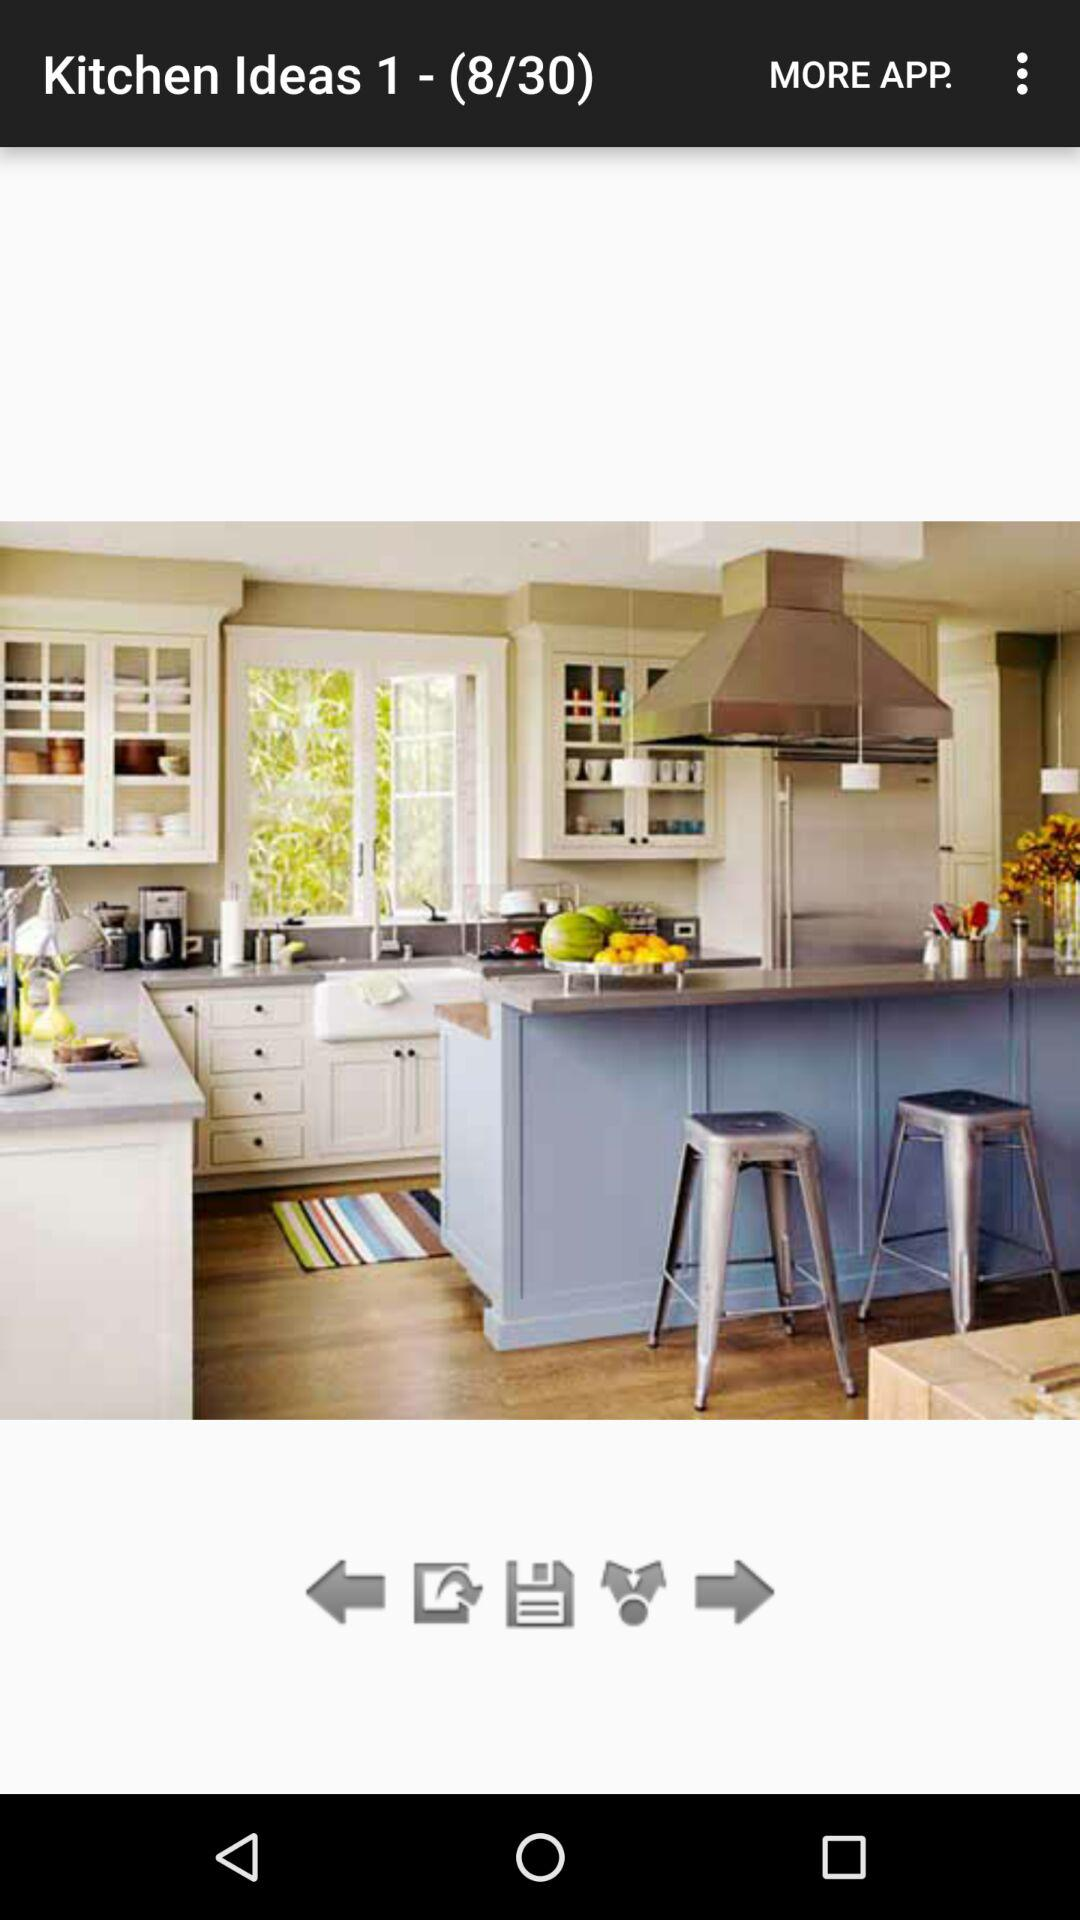How many sets are available? There are 30 sets available. 